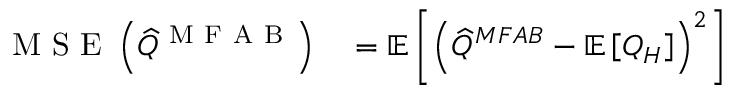<formula> <loc_0><loc_0><loc_500><loc_500>\begin{array} { r l } { M S E \left ( \widehat { Q } ^ { M F A B } \right ) } & = \mathbb { E } \left [ \left ( \widehat { Q } ^ { M F A B } - \mathbb { E } \left [ Q _ { H } \right ] \right ) ^ { 2 } \right ] } \end{array}</formula> 